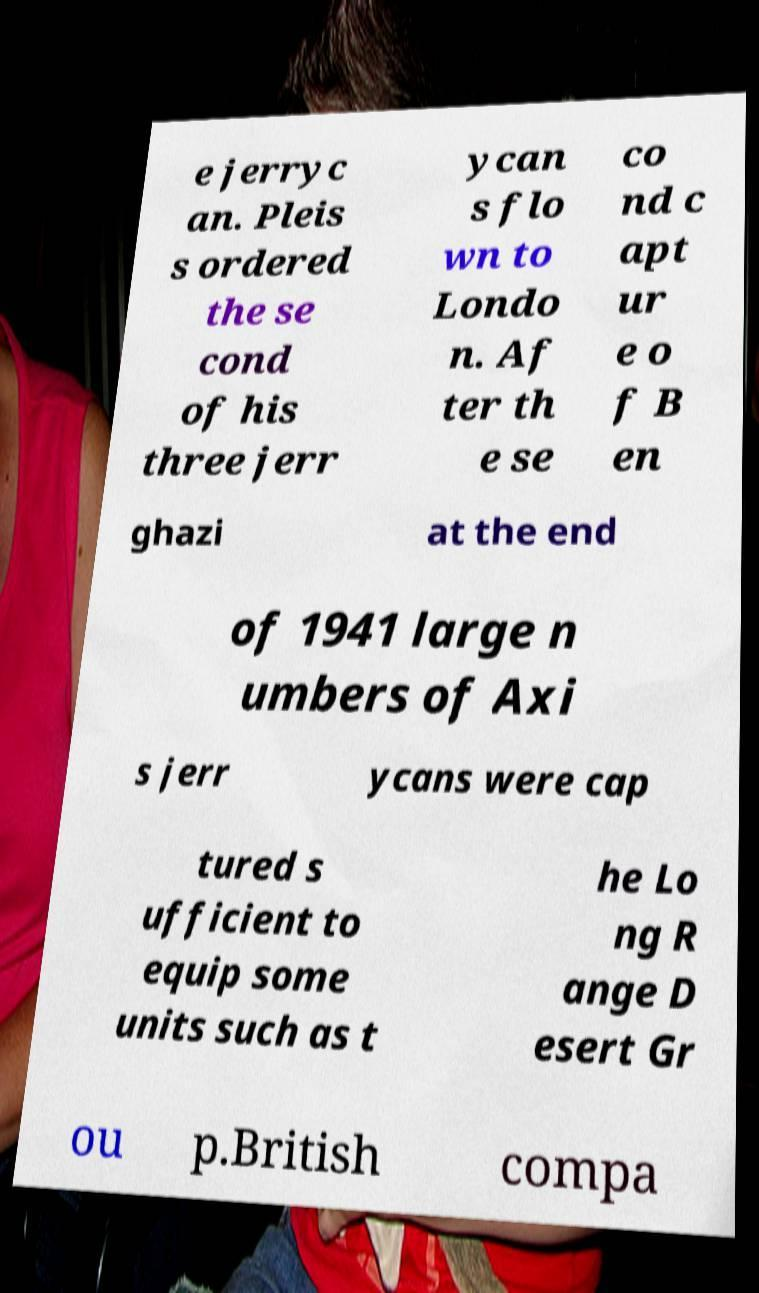Could you extract and type out the text from this image? e jerryc an. Pleis s ordered the se cond of his three jerr ycan s flo wn to Londo n. Af ter th e se co nd c apt ur e o f B en ghazi at the end of 1941 large n umbers of Axi s jerr ycans were cap tured s ufficient to equip some units such as t he Lo ng R ange D esert Gr ou p.British compa 